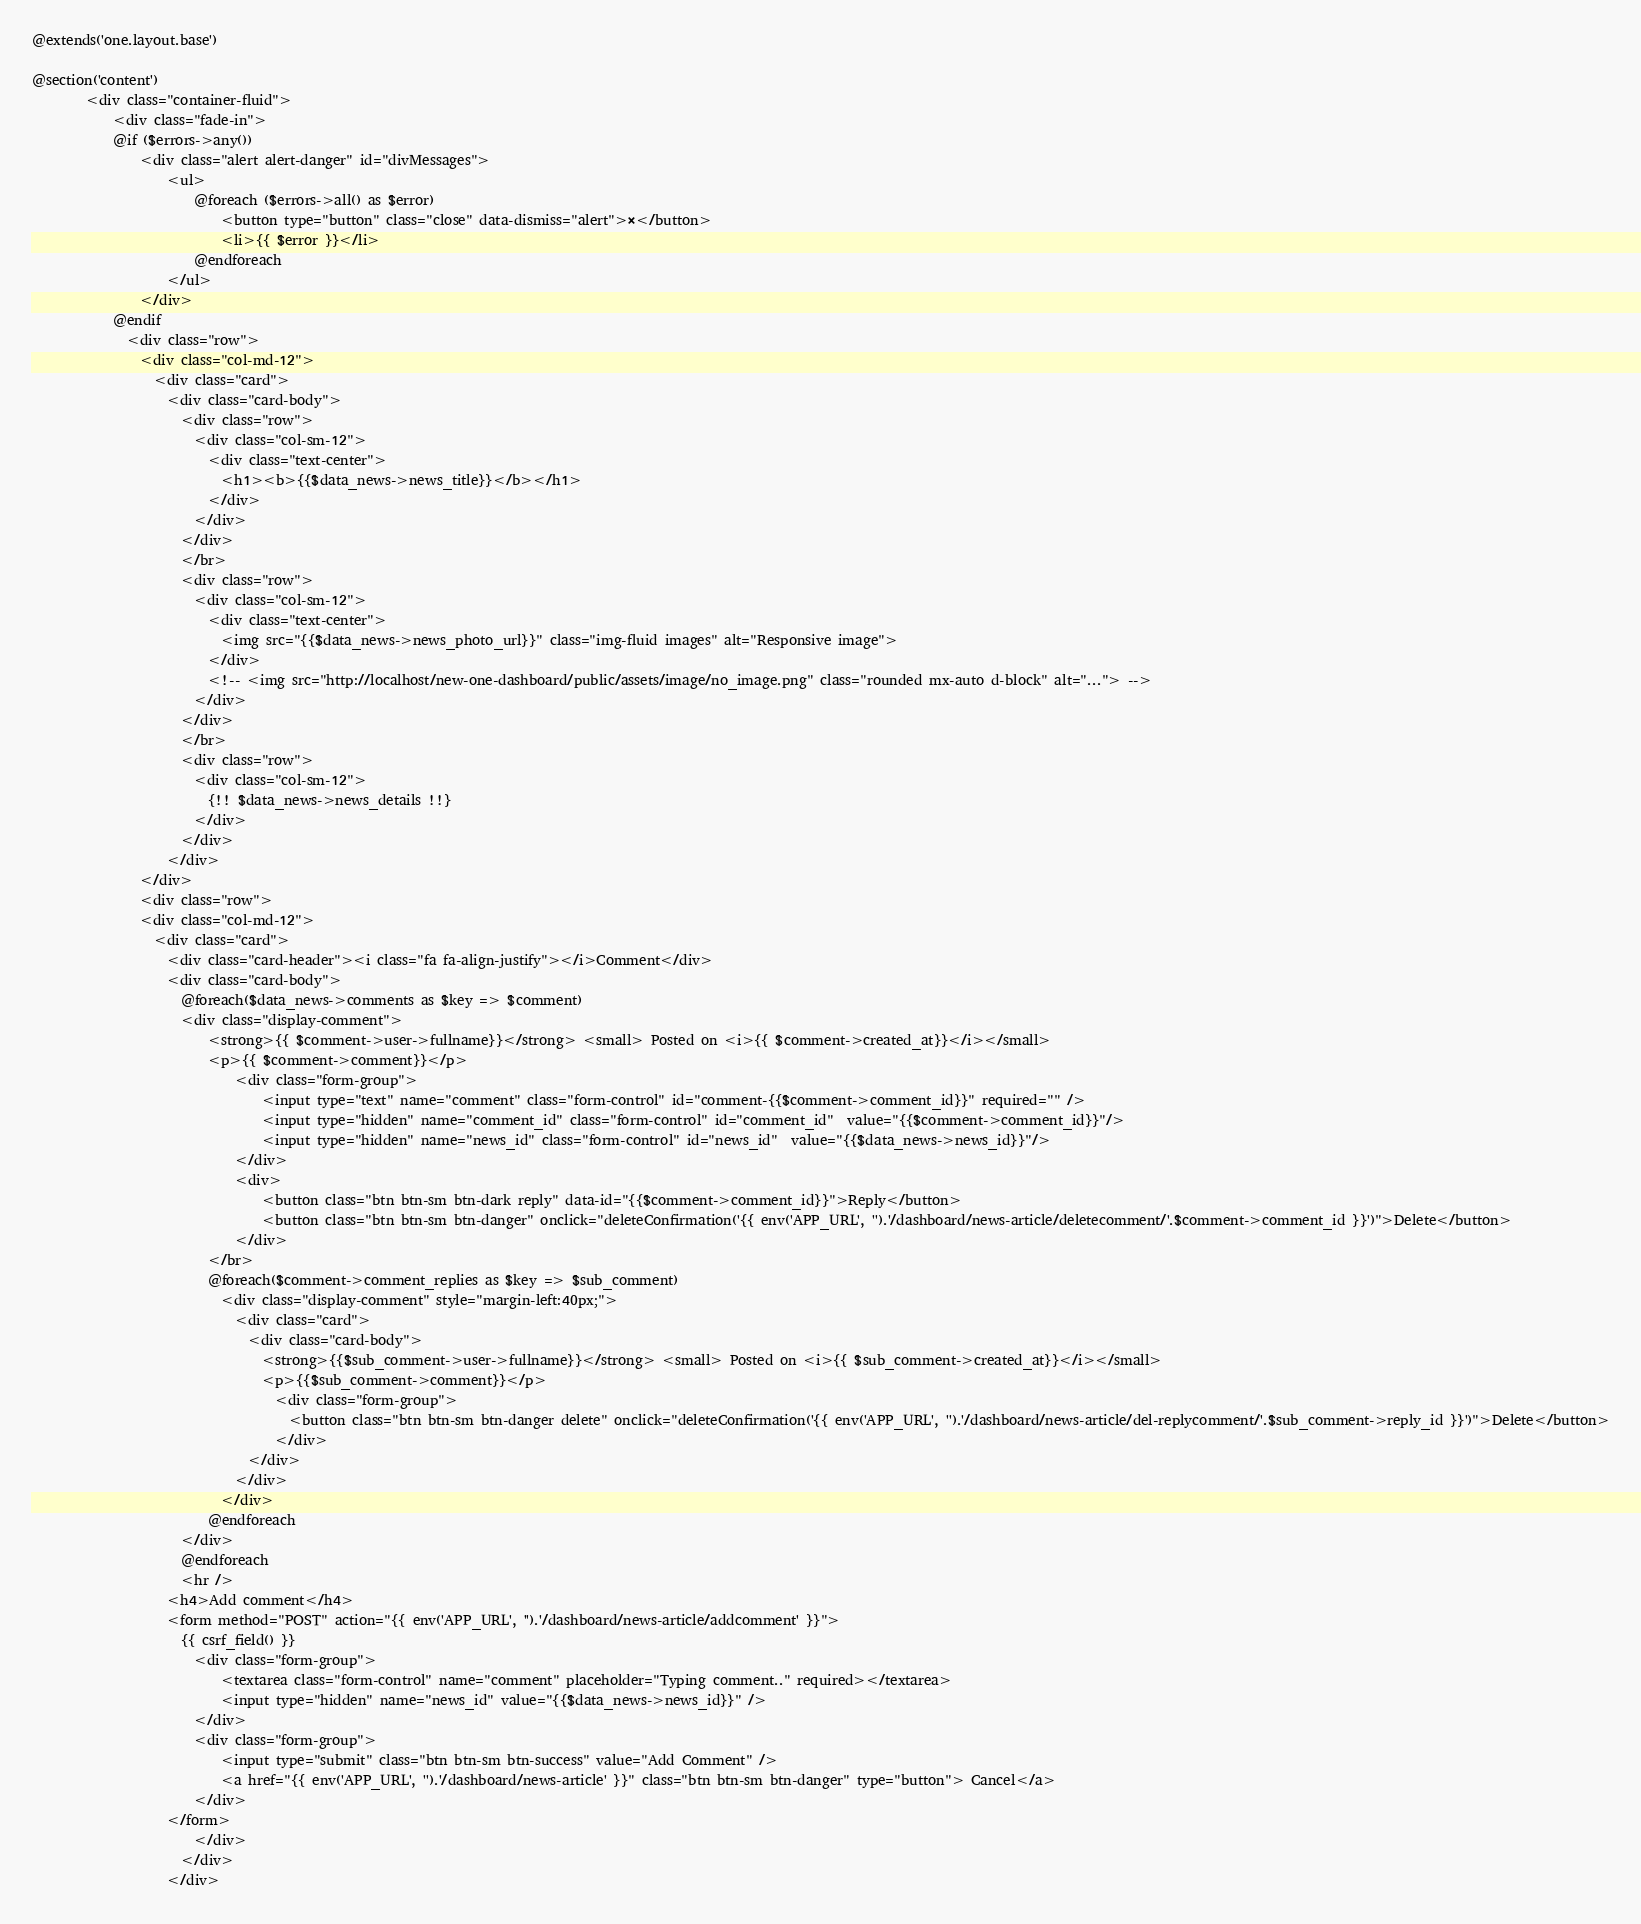<code> <loc_0><loc_0><loc_500><loc_500><_PHP_>@extends('one.layout.base')

@section('content')
        <div class="container-fluid">
            <div class="fade-in">
            @if ($errors->any())
                <div class="alert alert-danger" id="divMessages">
                    <ul>
                        @foreach ($errors->all() as $error)
                            <button type="button" class="close" data-dismiss="alert">×</button>
                            <li>{{ $error }}</li>
                        @endforeach
                    </ul>
                </div>
            @endif
              <div class="row">
                <div class="col-md-12">
                  <div class="card">
                    <div class="card-body">
                      <div class="row">
                        <div class="col-sm-12">
                          <div class="text-center">
                            <h1><b>{{$data_news->news_title}}</b></h1>
                          </div>
                        </div>
                      </div>
                      </br>
                      <div class="row">
                        <div class="col-sm-12">
                          <div class="text-center">
                            <img src="{{$data_news->news_photo_url}}" class="img-fluid images" alt="Responsive image">
                          </div>
                          <!-- <img src="http://localhost/new-one-dashboard/public/assets/image/no_image.png" class="rounded mx-auto d-block" alt="..."> -->
                        </div>
                      </div>
                      </br>
                      <div class="row">
                        <div class="col-sm-12">
                          {!! $data_news->news_details !!}
                        </div>
                      </div>
                    </div>
                </div>
                <div class="row">
                <div class="col-md-12">
                  <div class="card">
                    <div class="card-header"><i class="fa fa-align-justify"></i>Comment</div>
                    <div class="card-body">
                      @foreach($data_news->comments as $key => $comment)
                      <div class="display-comment">
                          <strong>{{ $comment->user->fullname}}</strong> <small> Posted on <i>{{ $comment->created_at}}</i></small>
                          <p>{{ $comment->comment}}</p>
                              <div class="form-group">
                                  <input type="text" name="comment" class="form-control" id="comment-{{$comment->comment_id}}" required="" />
                                  <input type="hidden" name="comment_id" class="form-control" id="comment_id"  value="{{$comment->comment_id}}"/>
                                  <input type="hidden" name="news_id" class="form-control" id="news_id"  value="{{$data_news->news_id}}"/>
                              </div>
                              <div>
                                  <button class="btn btn-sm btn-dark reply" data-id="{{$comment->comment_id}}">Reply</button>
                                  <button class="btn btn-sm btn-danger" onclick="deleteConfirmation('{{ env('APP_URL', '').'/dashboard/news-article/deletecomment/'.$comment->comment_id }}')">Delete</button>
                              </div>
                          </br>
                          @foreach($comment->comment_replies as $key => $sub_comment)
                            <div class="display-comment" style="margin-left:40px;">
                              <div class="card">
                                <div class="card-body">
                                  <strong>{{$sub_comment->user->fullname}}</strong> <small> Posted on <i>{{ $sub_comment->created_at}}</i></small>
                                  <p>{{$sub_comment->comment}}</p>
                                    <div class="form-group">
                                      <button class="btn btn-sm btn-danger delete" onclick="deleteConfirmation('{{ env('APP_URL', '').'/dashboard/news-article/del-replycomment/'.$sub_comment->reply_id }}')">Delete</button>
                                    </div>
                                </div>
                              </div>
                            </div>
                          @endforeach
                      </div>
                      @endforeach
                      <hr />
                    <h4>Add comment</h4>
                    <form method="POST" action="{{ env('APP_URL', '').'/dashboard/news-article/addcomment' }}">
                      {{ csrf_field() }}
                        <div class="form-group">
                            <textarea class="form-control" name="comment" placeholder="Typing comment.." required></textarea>
                            <input type="hidden" name="news_id" value="{{$data_news->news_id}}" />
                        </div>
                        <div class="form-group">
                            <input type="submit" class="btn btn-sm btn-success" value="Add Comment" />
                            <a href="{{ env('APP_URL', '').'/dashboard/news-article' }}" class="btn btn-sm btn-danger" type="button"> Cancel</a>
                        </div>
                    </form>
                        </div>
                      </div>
                    </div></code> 